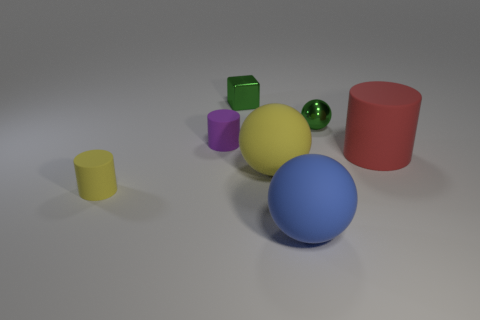What number of other things are there of the same color as the big matte cylinder?
Provide a succinct answer. 0. Is the green thing to the right of the cube made of the same material as the large yellow ball?
Your response must be concise. No. What size is the shiny thing that is right of the tiny metallic block behind the large red rubber cylinder to the right of the green ball?
Make the answer very short. Small. The thing that is the same material as the small green ball is what size?
Offer a terse response. Small. There is a cylinder that is behind the yellow sphere and to the left of the large yellow ball; what is its color?
Your response must be concise. Purple. There is a yellow matte thing that is behind the small yellow thing; is it the same shape as the yellow matte thing that is left of the large yellow object?
Ensure brevity in your answer.  No. There is a green object behind the green metallic ball; what is its material?
Provide a succinct answer. Metal. There is a metal object that is the same color as the tiny shiny cube; what size is it?
Keep it short and to the point. Small. How many things are spheres behind the large blue thing or large blue rubber spheres?
Provide a short and direct response. 3. Are there the same number of cylinders to the right of the purple matte cylinder and purple matte spheres?
Give a very brief answer. No. 